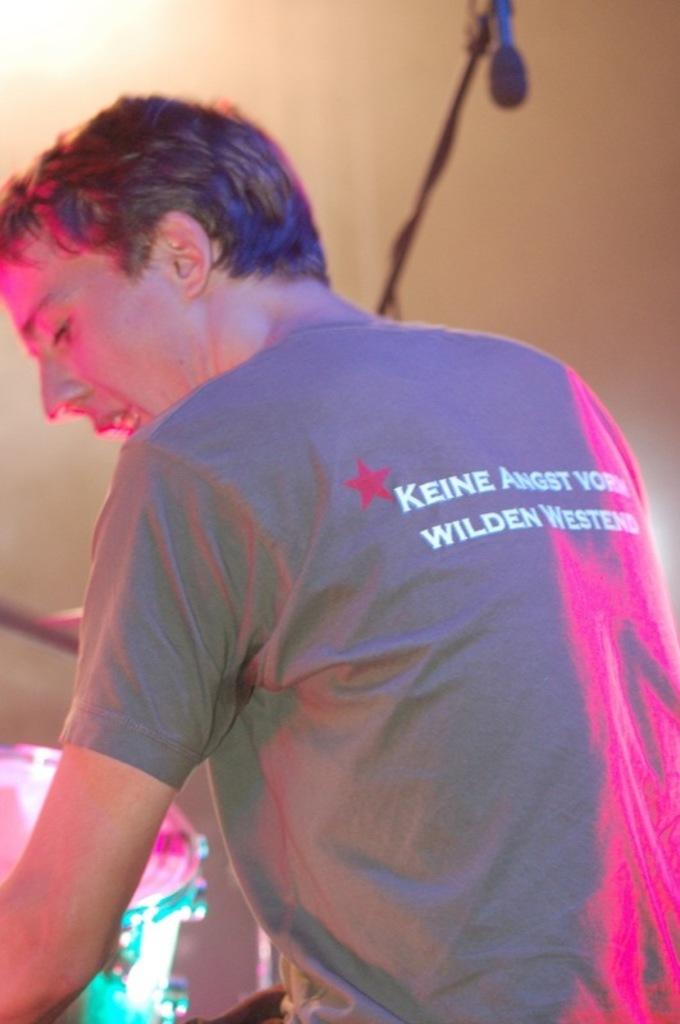What is the main subject of the image? There is a person in the image. What can be seen on the left side of the image? There is a band on the left side of the image. What is visible in the background of the image? There is a wire and an object visible in the background of the image, as well as a wall. What type of stamp is being used by the person in the image? There is no stamp present in the image, so it cannot be determined what type of stamp might be used. 